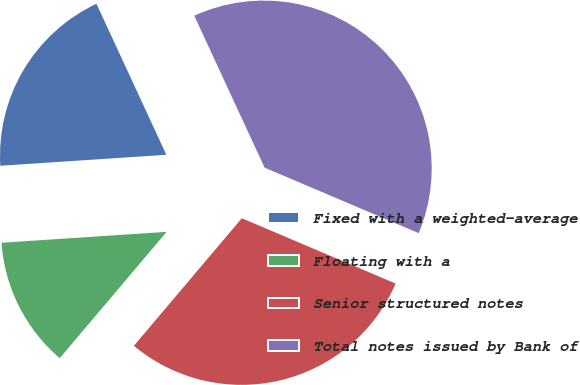Convert chart. <chart><loc_0><loc_0><loc_500><loc_500><pie_chart><fcel>Fixed with a weighted-average<fcel>Floating with a<fcel>Senior structured notes<fcel>Total notes issued by Bank of<nl><fcel>19.15%<fcel>12.77%<fcel>29.78%<fcel>38.29%<nl></chart> 